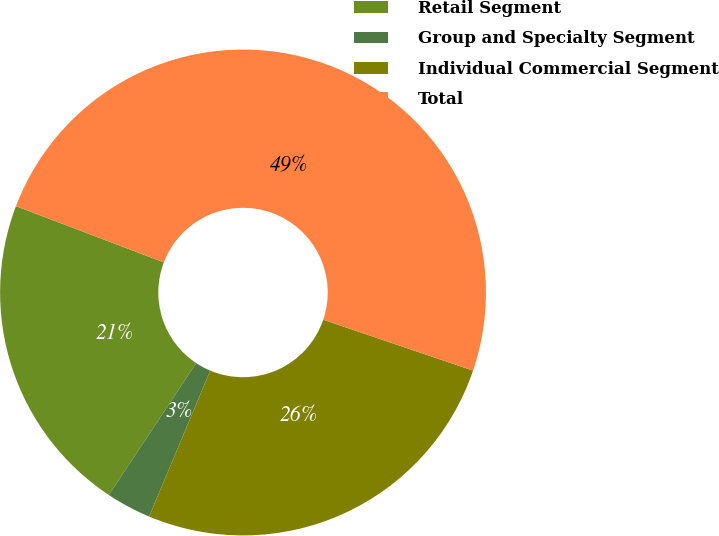Convert chart. <chart><loc_0><loc_0><loc_500><loc_500><pie_chart><fcel>Retail Segment<fcel>Group and Specialty Segment<fcel>Individual Commercial Segment<fcel>Total<nl><fcel>21.47%<fcel>3.0%<fcel>26.11%<fcel>49.43%<nl></chart> 